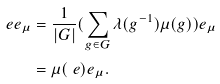<formula> <loc_0><loc_0><loc_500><loc_500>\ e e _ { \mu } & = \frac { 1 } { | G | } ( \sum _ { g \in G } \lambda ( g ^ { - 1 } ) \mu ( g ) ) e _ { \mu } \\ & = \mu ( \ e ) e _ { \mu } .</formula> 